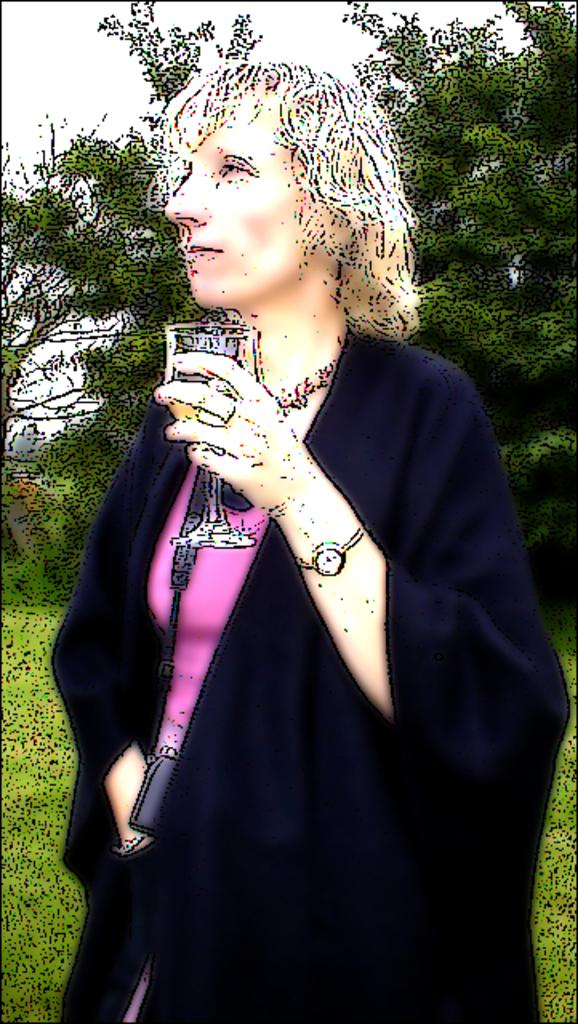What is the main subject of the image? There is a painting in the image. What is the woman in the image doing? The woman is holding a glass in the image. What type of vegetation can be seen in the image? There are green color trees in the image. What is the color of the grass on the ground in the image? There is green grass on the ground in the image. What type of apple is being cut by the woman with a knife in the image? There is no apple or knife present in the image; the woman is holding a glass. 